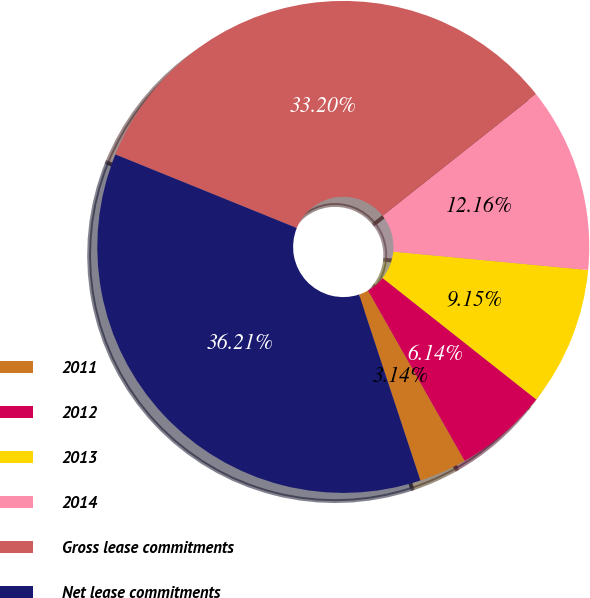<chart> <loc_0><loc_0><loc_500><loc_500><pie_chart><fcel>2011<fcel>2012<fcel>2013<fcel>2014<fcel>Gross lease commitments<fcel>Net lease commitments<nl><fcel>3.14%<fcel>6.14%<fcel>9.15%<fcel>12.16%<fcel>33.2%<fcel>36.21%<nl></chart> 